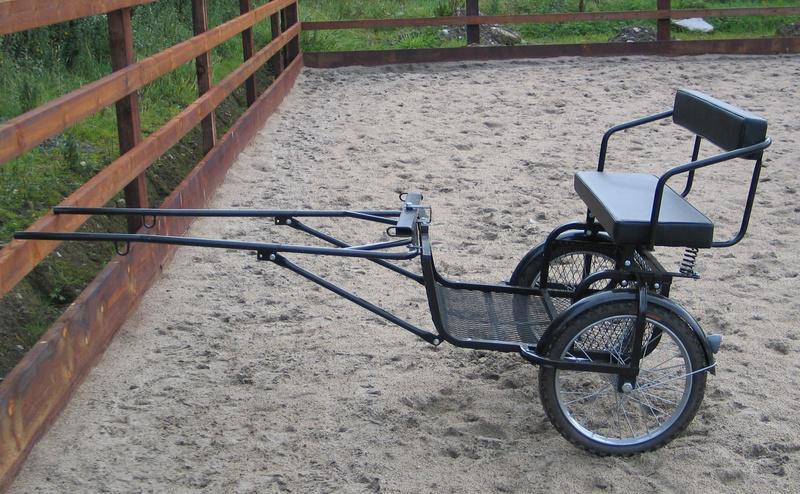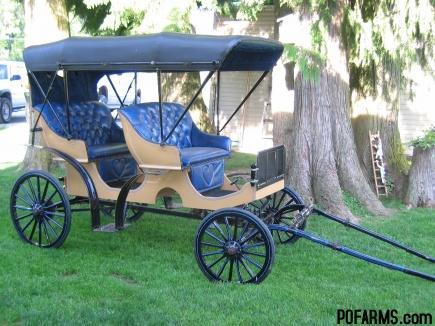The first image is the image on the left, the second image is the image on the right. Given the left and right images, does the statement "An image shows a four-wheeled buggy with a canopy over an upholstered seat." hold true? Answer yes or no. Yes. The first image is the image on the left, the second image is the image on the right. Evaluate the accuracy of this statement regarding the images: "There are two carts, but only one of them has a canopy.". Is it true? Answer yes or no. Yes. 